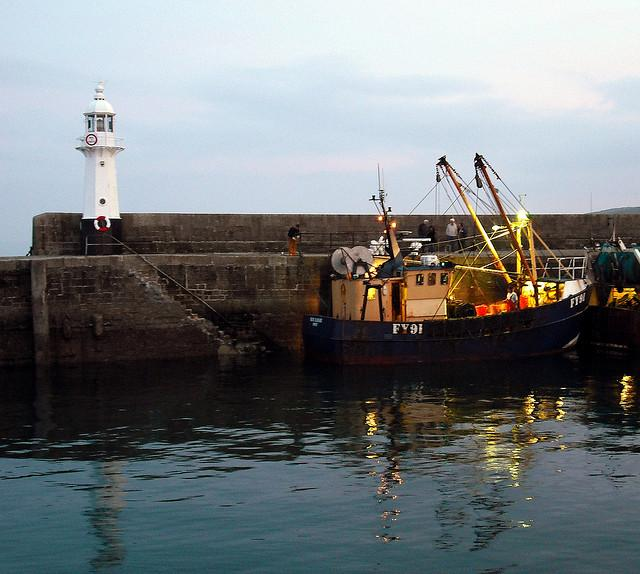When it is dark at night what will the boats use as navigation?

Choices:
A) moonlight
B) flashlights
C) radar
D) lighthouse lighthouse 